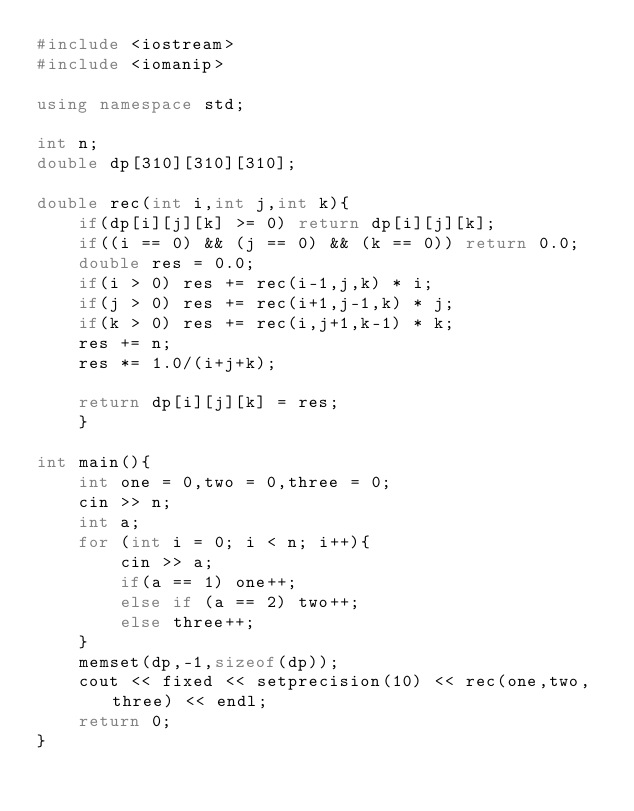Convert code to text. <code><loc_0><loc_0><loc_500><loc_500><_C++_>#include <iostream>
#include <iomanip>

using namespace std;

int n;
double dp[310][310][310];

double rec(int i,int j,int k){
    if(dp[i][j][k] >= 0) return dp[i][j][k];
    if((i == 0) && (j == 0) && (k == 0)) return 0.0;
    double res = 0.0;
    if(i > 0) res += rec(i-1,j,k) * i;
    if(j > 0) res += rec(i+1,j-1,k) * j;
    if(k > 0) res += rec(i,j+1,k-1) * k;
    res += n;
    res *= 1.0/(i+j+k);

    return dp[i][j][k] = res;
    }

int main(){
    int one = 0,two = 0,three = 0;
    cin >> n;
    int a;
    for (int i = 0; i < n; i++){
        cin >> a;
        if(a == 1) one++;
        else if (a == 2) two++;
        else three++;
    }
    memset(dp,-1,sizeof(dp));
    cout << fixed << setprecision(10) << rec(one,two,three) << endl; 
    return 0;
}</code> 